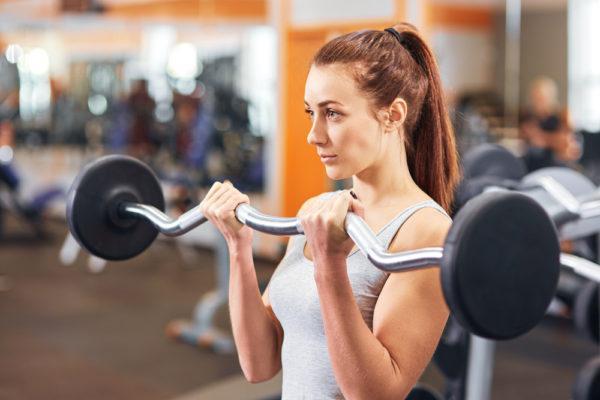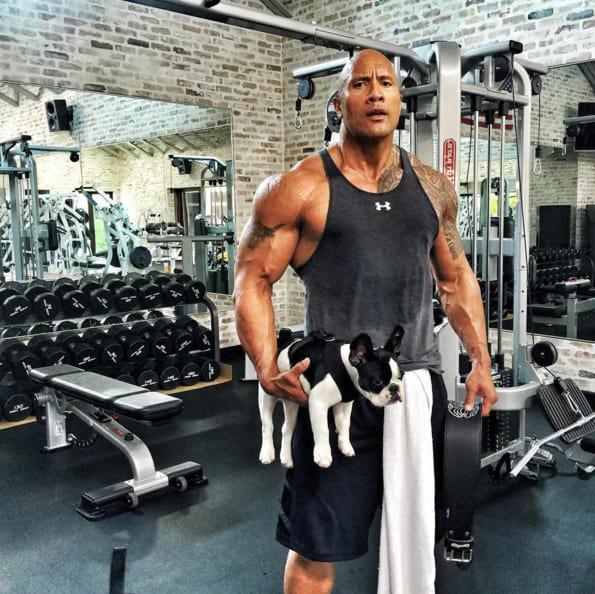The first image is the image on the left, the second image is the image on the right. For the images displayed, is the sentence "The left and right image contains  a total of four people working out." factually correct? Answer yes or no. No. The first image is the image on the left, the second image is the image on the right. Assess this claim about the two images: "At least one of the images has a man.". Correct or not? Answer yes or no. Yes. 